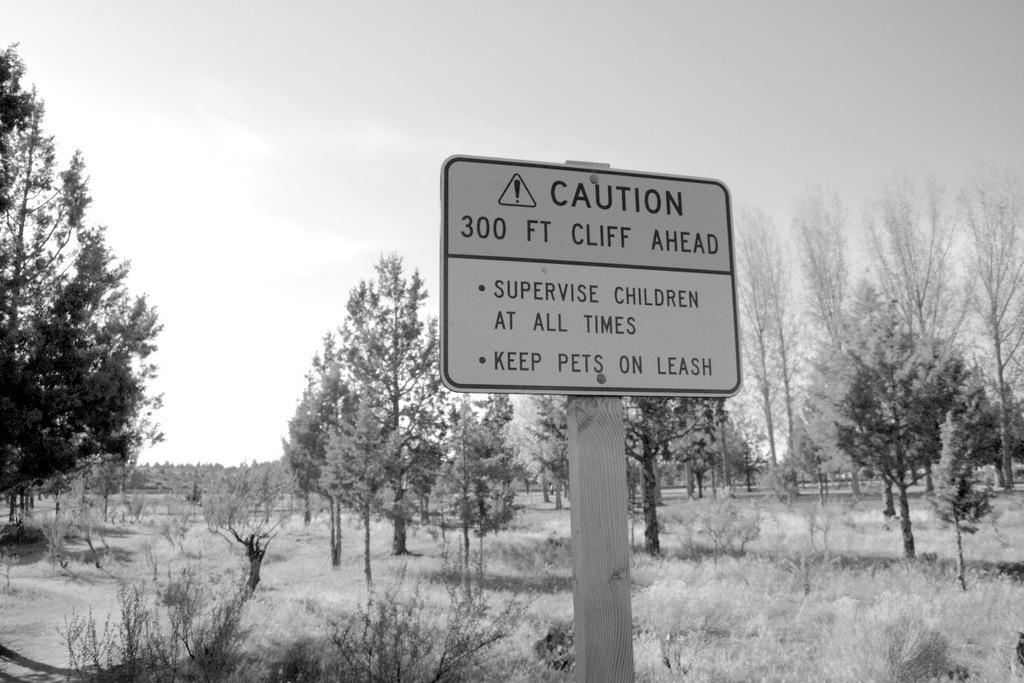In one or two sentences, can you explain what this image depicts? In the picture we can see a caution board to the wooden pole and behind it, we can see some plants, dried grass, trees and sky. 